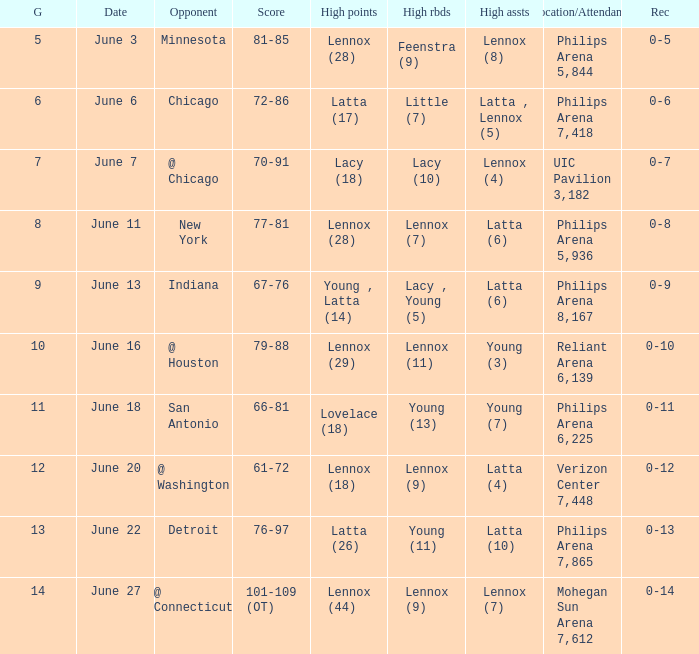What stadium hosted the June 7 game and how many visitors were there? UIC Pavilion 3,182. Can you give me this table as a dict? {'header': ['G', 'Date', 'Opponent', 'Score', 'High points', 'High rbds', 'High assts', 'Location/Attendance', 'Rec'], 'rows': [['5', 'June 3', 'Minnesota', '81-85', 'Lennox (28)', 'Feenstra (9)', 'Lennox (8)', 'Philips Arena 5,844', '0-5'], ['6', 'June 6', 'Chicago', '72-86', 'Latta (17)', 'Little (7)', 'Latta , Lennox (5)', 'Philips Arena 7,418', '0-6'], ['7', 'June 7', '@ Chicago', '70-91', 'Lacy (18)', 'Lacy (10)', 'Lennox (4)', 'UIC Pavilion 3,182', '0-7'], ['8', 'June 11', 'New York', '77-81', 'Lennox (28)', 'Lennox (7)', 'Latta (6)', 'Philips Arena 5,936', '0-8'], ['9', 'June 13', 'Indiana', '67-76', 'Young , Latta (14)', 'Lacy , Young (5)', 'Latta (6)', 'Philips Arena 8,167', '0-9'], ['10', 'June 16', '@ Houston', '79-88', 'Lennox (29)', 'Lennox (11)', 'Young (3)', 'Reliant Arena 6,139', '0-10'], ['11', 'June 18', 'San Antonio', '66-81', 'Lovelace (18)', 'Young (13)', 'Young (7)', 'Philips Arena 6,225', '0-11'], ['12', 'June 20', '@ Washington', '61-72', 'Lennox (18)', 'Lennox (9)', 'Latta (4)', 'Verizon Center 7,448', '0-12'], ['13', 'June 22', 'Detroit', '76-97', 'Latta (26)', 'Young (11)', 'Latta (10)', 'Philips Arena 7,865', '0-13'], ['14', 'June 27', '@ Connecticut', '101-109 (OT)', 'Lennox (44)', 'Lennox (9)', 'Lennox (7)', 'Mohegan Sun Arena 7,612', '0-14']]} 